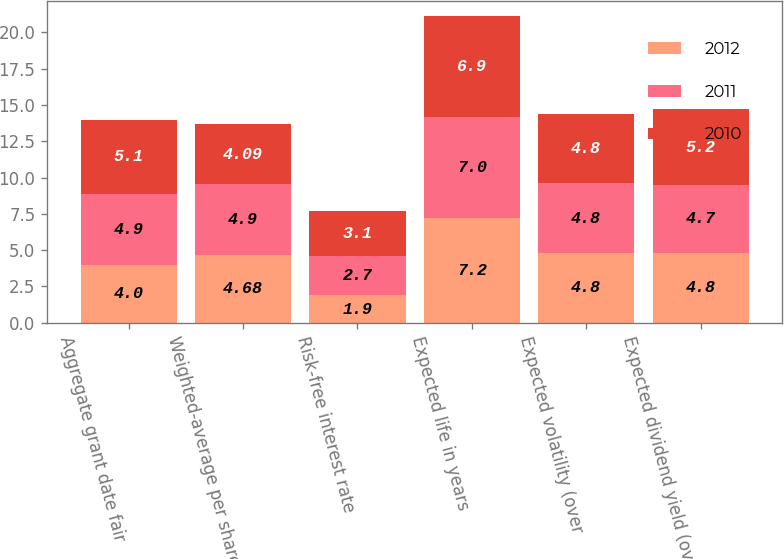<chart> <loc_0><loc_0><loc_500><loc_500><stacked_bar_chart><ecel><fcel>Aggregate grant date fair<fcel>Weighted-average per share<fcel>Risk-free interest rate<fcel>Expected life in years<fcel>Expected volatility (over<fcel>Expected dividend yield (over<nl><fcel>2012<fcel>4<fcel>4.68<fcel>1.9<fcel>7.2<fcel>4.8<fcel>4.8<nl><fcel>2011<fcel>4.9<fcel>4.9<fcel>2.7<fcel>7<fcel>4.8<fcel>4.7<nl><fcel>2010<fcel>5.1<fcel>4.09<fcel>3.1<fcel>6.9<fcel>4.8<fcel>5.2<nl></chart> 